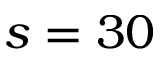<formula> <loc_0><loc_0><loc_500><loc_500>s = 3 0</formula> 